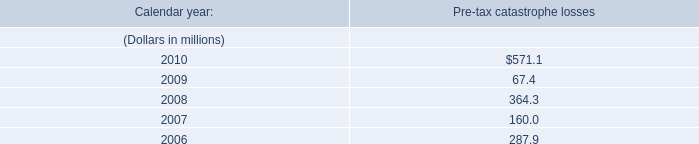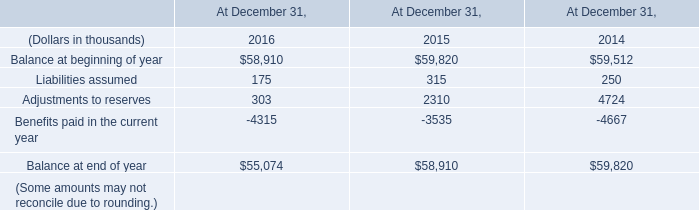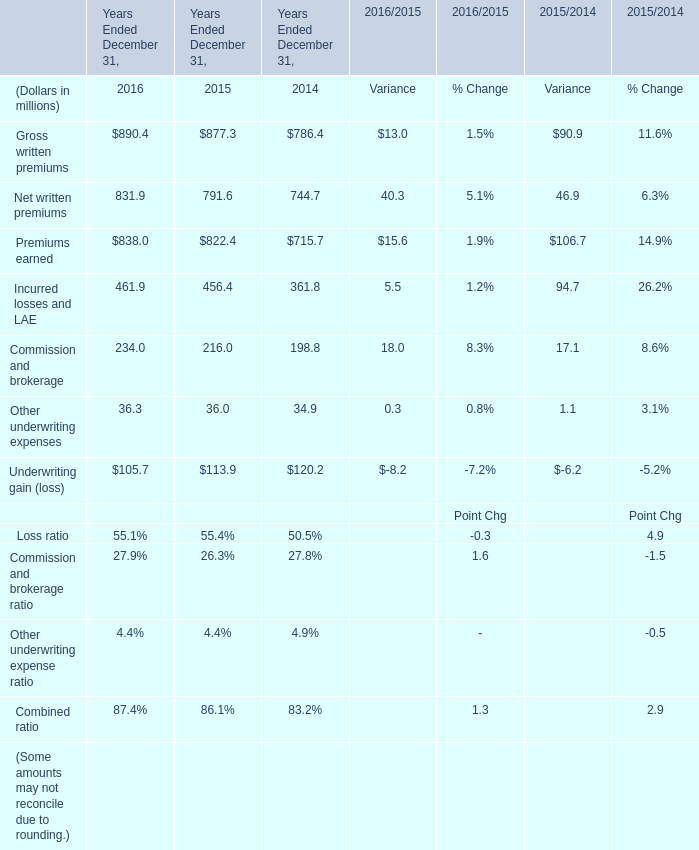In the year with largest amount of Incurred losses and LAE, what's the increasing rate of Commission and brokerage? 
Computations: ((234 - 216) / 216)
Answer: 0.08333. 